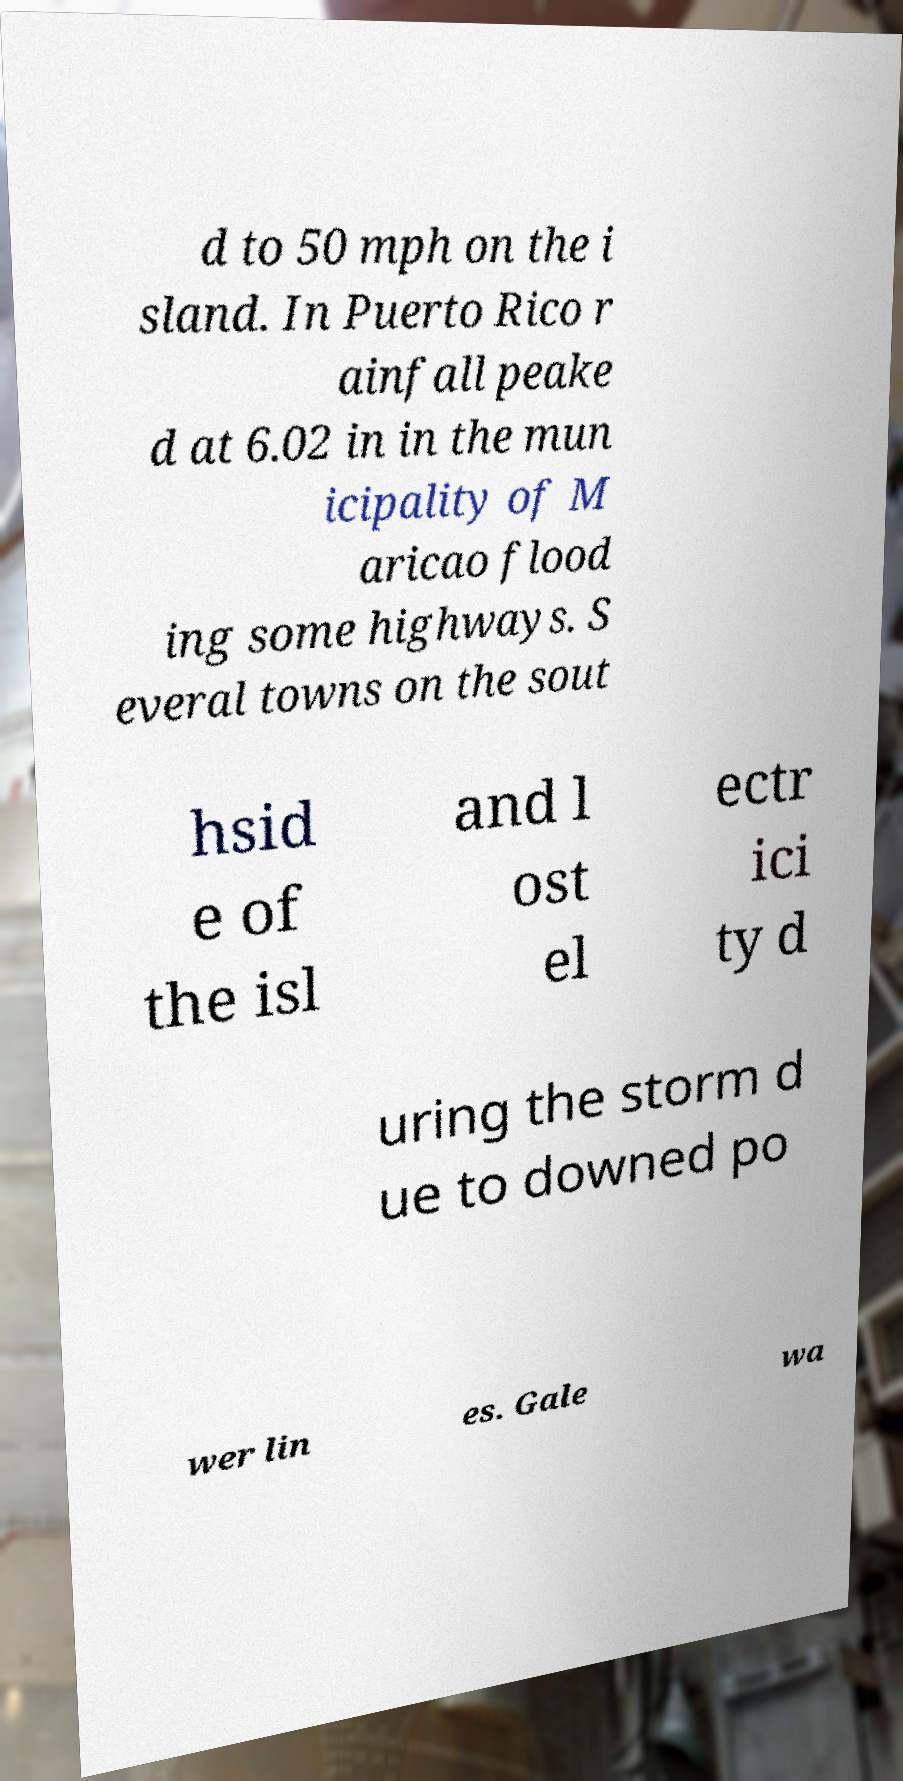Can you read and provide the text displayed in the image?This photo seems to have some interesting text. Can you extract and type it out for me? d to 50 mph on the i sland. In Puerto Rico r ainfall peake d at 6.02 in in the mun icipality of M aricao flood ing some highways. S everal towns on the sout hsid e of the isl and l ost el ectr ici ty d uring the storm d ue to downed po wer lin es. Gale wa 